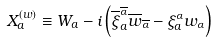Convert formula to latex. <formula><loc_0><loc_0><loc_500><loc_500>X _ { a } ^ { ( w ) } \equiv W _ { a } - i \left ( \overline { \xi } _ { a } ^ { \overline { \alpha } } \overline { w } _ { \overline { \alpha } } - \xi _ { a } ^ { \alpha } w _ { \alpha } \right )</formula> 